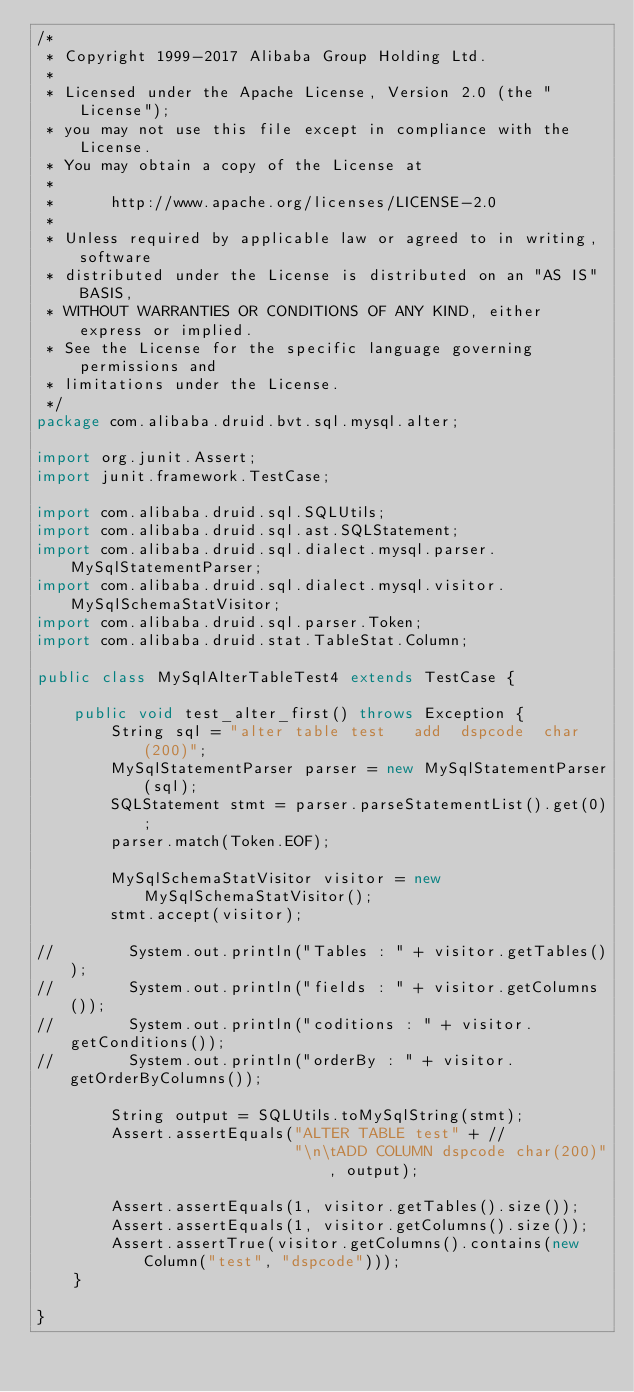Convert code to text. <code><loc_0><loc_0><loc_500><loc_500><_Java_>/*
 * Copyright 1999-2017 Alibaba Group Holding Ltd.
 *
 * Licensed under the Apache License, Version 2.0 (the "License");
 * you may not use this file except in compliance with the License.
 * You may obtain a copy of the License at
 *
 *      http://www.apache.org/licenses/LICENSE-2.0
 *
 * Unless required by applicable law or agreed to in writing, software
 * distributed under the License is distributed on an "AS IS" BASIS,
 * WITHOUT WARRANTIES OR CONDITIONS OF ANY KIND, either express or implied.
 * See the License for the specific language governing permissions and
 * limitations under the License.
 */
package com.alibaba.druid.bvt.sql.mysql.alter;

import org.junit.Assert;
import junit.framework.TestCase;

import com.alibaba.druid.sql.SQLUtils;
import com.alibaba.druid.sql.ast.SQLStatement;
import com.alibaba.druid.sql.dialect.mysql.parser.MySqlStatementParser;
import com.alibaba.druid.sql.dialect.mysql.visitor.MySqlSchemaStatVisitor;
import com.alibaba.druid.sql.parser.Token;
import com.alibaba.druid.stat.TableStat.Column;

public class MySqlAlterTableTest4 extends TestCase {

    public void test_alter_first() throws Exception {
        String sql = "alter table test   add  dspcode  char(200)";
        MySqlStatementParser parser = new MySqlStatementParser(sql);
        SQLStatement stmt = parser.parseStatementList().get(0);
        parser.match(Token.EOF);

        MySqlSchemaStatVisitor visitor = new MySqlSchemaStatVisitor();
        stmt.accept(visitor);

//        System.out.println("Tables : " + visitor.getTables());
//        System.out.println("fields : " + visitor.getColumns());
//        System.out.println("coditions : " + visitor.getConditions());
//        System.out.println("orderBy : " + visitor.getOrderByColumns());

        String output = SQLUtils.toMySqlString(stmt);
        Assert.assertEquals("ALTER TABLE test" + //
                            "\n\tADD COLUMN dspcode char(200)", output);
        
        Assert.assertEquals(1, visitor.getTables().size());
        Assert.assertEquals(1, visitor.getColumns().size());
        Assert.assertTrue(visitor.getColumns().contains(new Column("test", "dspcode")));
    }

}
</code> 